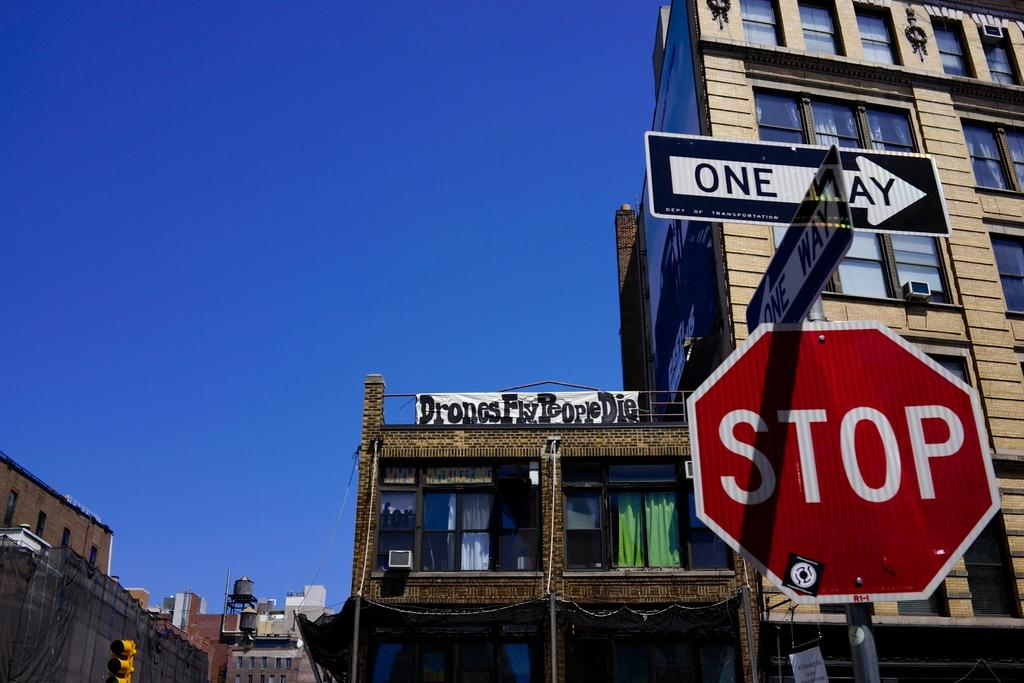<image>
Share a concise interpretation of the image provided. Two one-way signs mounted on top of a stop sign. 